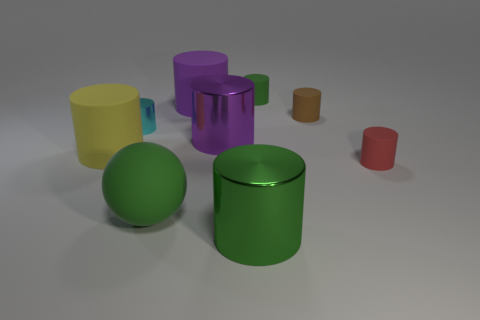Does the lighting in the image suggest a particular time of day or setting? The lighting in the image is diffuse and artificial, lacking any strong directional shadows or warm tones that would suggest a natural time of day. This lighting is typical for a controlled indoor environment, possibly a studio setting for product visualization. 